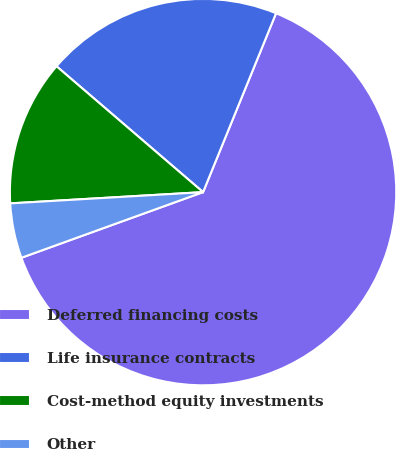Convert chart. <chart><loc_0><loc_0><loc_500><loc_500><pie_chart><fcel>Deferred financing costs<fcel>Life insurance contracts<fcel>Cost-method equity investments<fcel>Other<nl><fcel>63.31%<fcel>19.87%<fcel>12.22%<fcel>4.59%<nl></chart> 